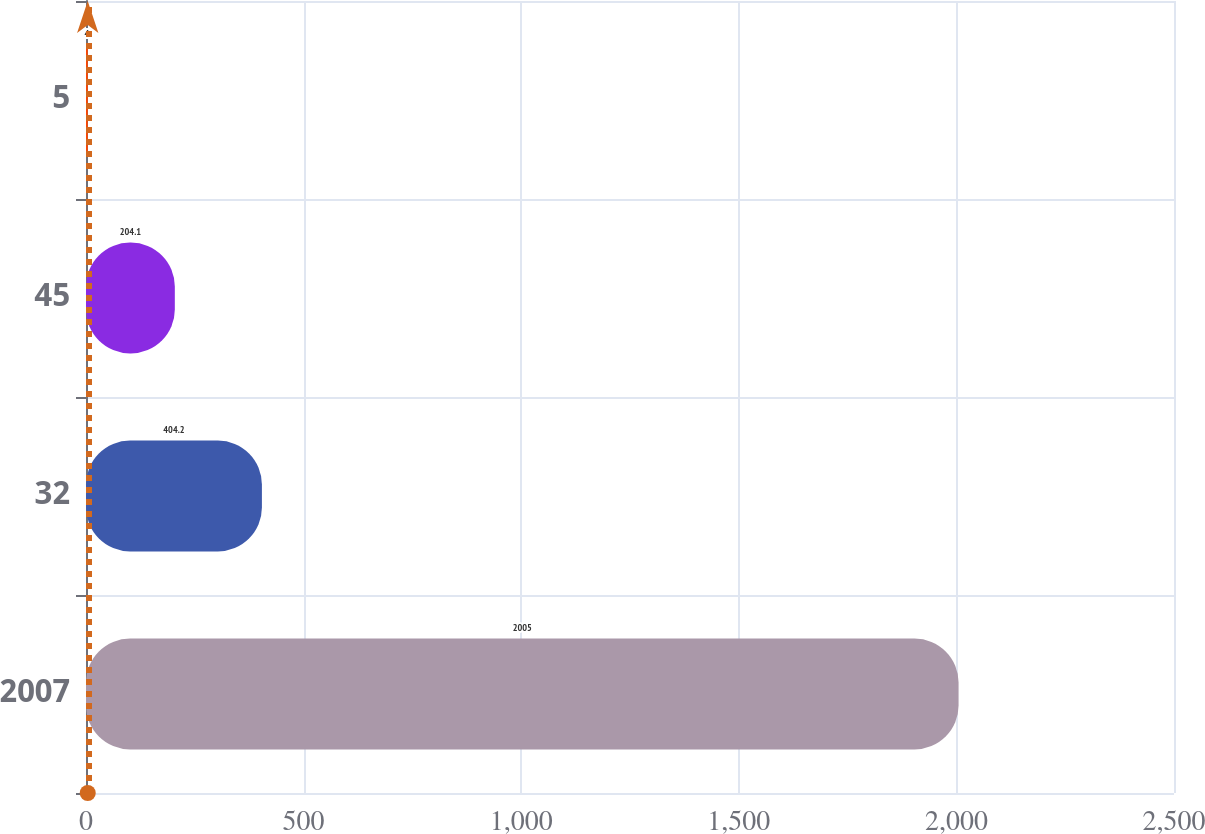Convert chart to OTSL. <chart><loc_0><loc_0><loc_500><loc_500><bar_chart><fcel>2007<fcel>32<fcel>45<fcel>5<nl><fcel>2005<fcel>404.2<fcel>204.1<fcel>4<nl></chart> 